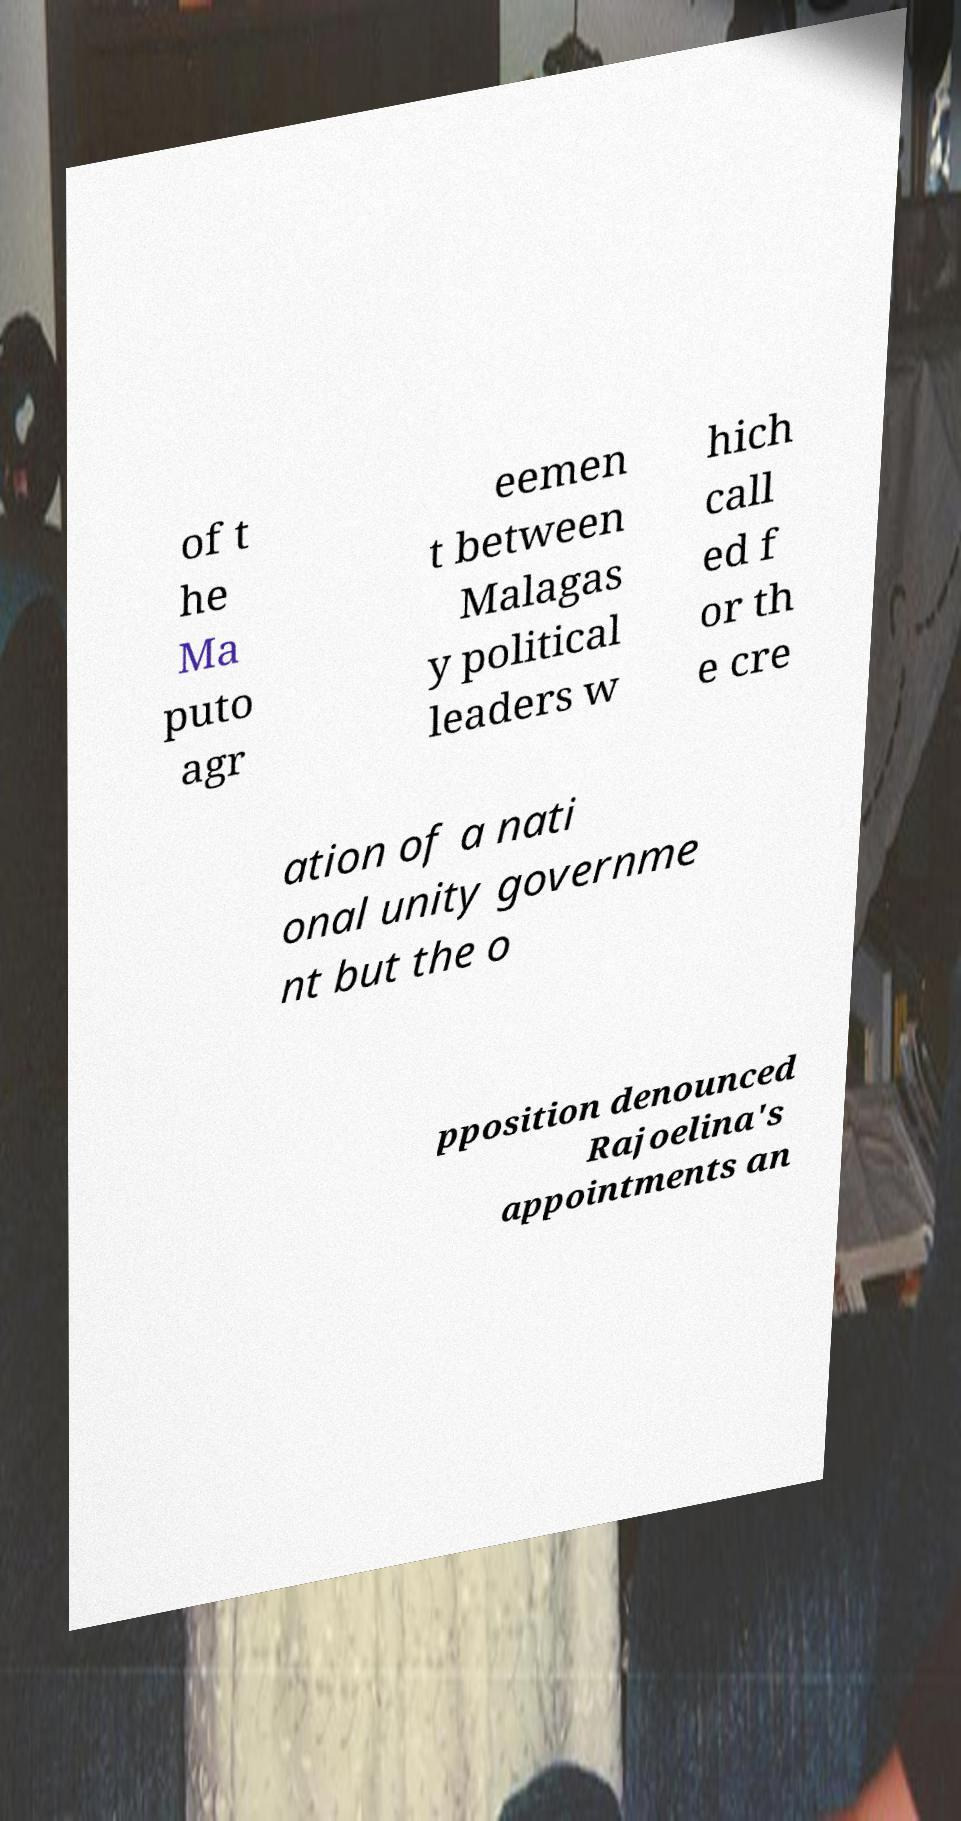Please read and relay the text visible in this image. What does it say? of t he Ma puto agr eemen t between Malagas y political leaders w hich call ed f or th e cre ation of a nati onal unity governme nt but the o pposition denounced Rajoelina's appointments an 